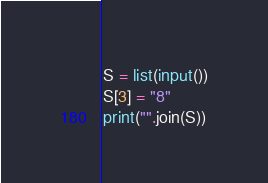Convert code to text. <code><loc_0><loc_0><loc_500><loc_500><_Python_>S = list(input())
S[3] = "8"
print("".join(S))</code> 